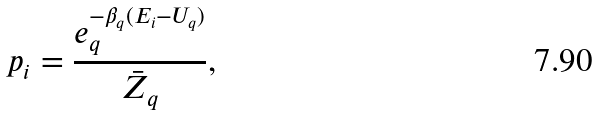Convert formula to latex. <formula><loc_0><loc_0><loc_500><loc_500>p _ { i } = \frac { e _ { q } ^ { - \beta _ { q } ( E _ { i } - U _ { q } ) } } { \bar { Z } _ { q } } ,</formula> 